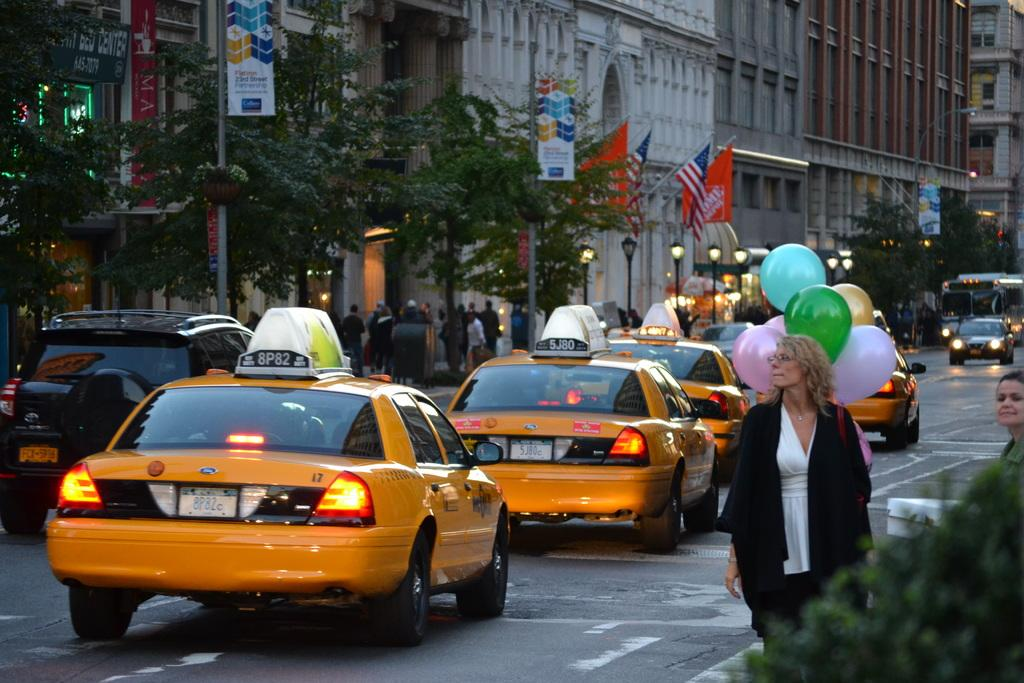<image>
Summarize the visual content of the image. Yellow cabs with tag numbers 8P82 and 5J80 drive through NYC streets. 